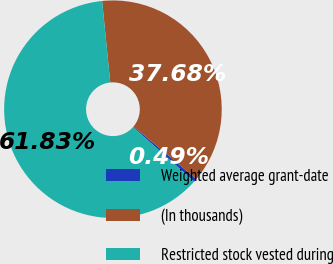Convert chart to OTSL. <chart><loc_0><loc_0><loc_500><loc_500><pie_chart><fcel>Weighted average grant-date<fcel>(In thousands)<fcel>Restricted stock vested during<nl><fcel>0.49%<fcel>37.68%<fcel>61.83%<nl></chart> 